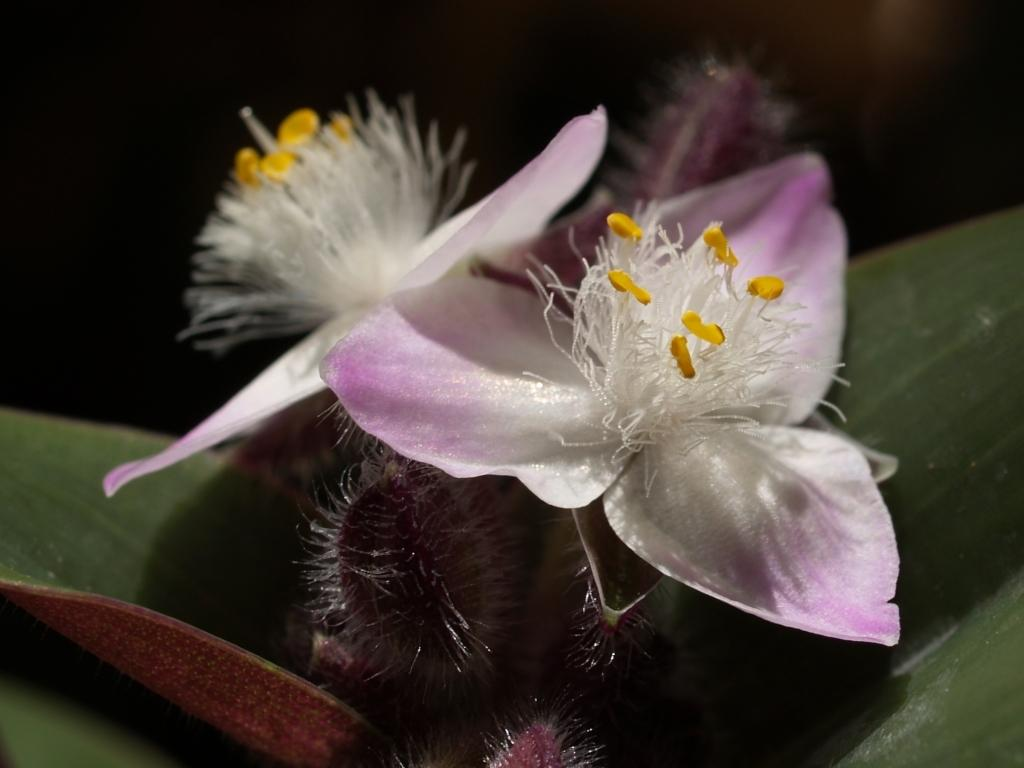What is the main subject in the center of the image? The main subject in the center of the image is a flower. Can you describe the flower's location in the image? The flower is on a plant in the image. What type of potato is being used as a fan in the image? There is no potato or fan present in the image; it features a flower on a plant. 